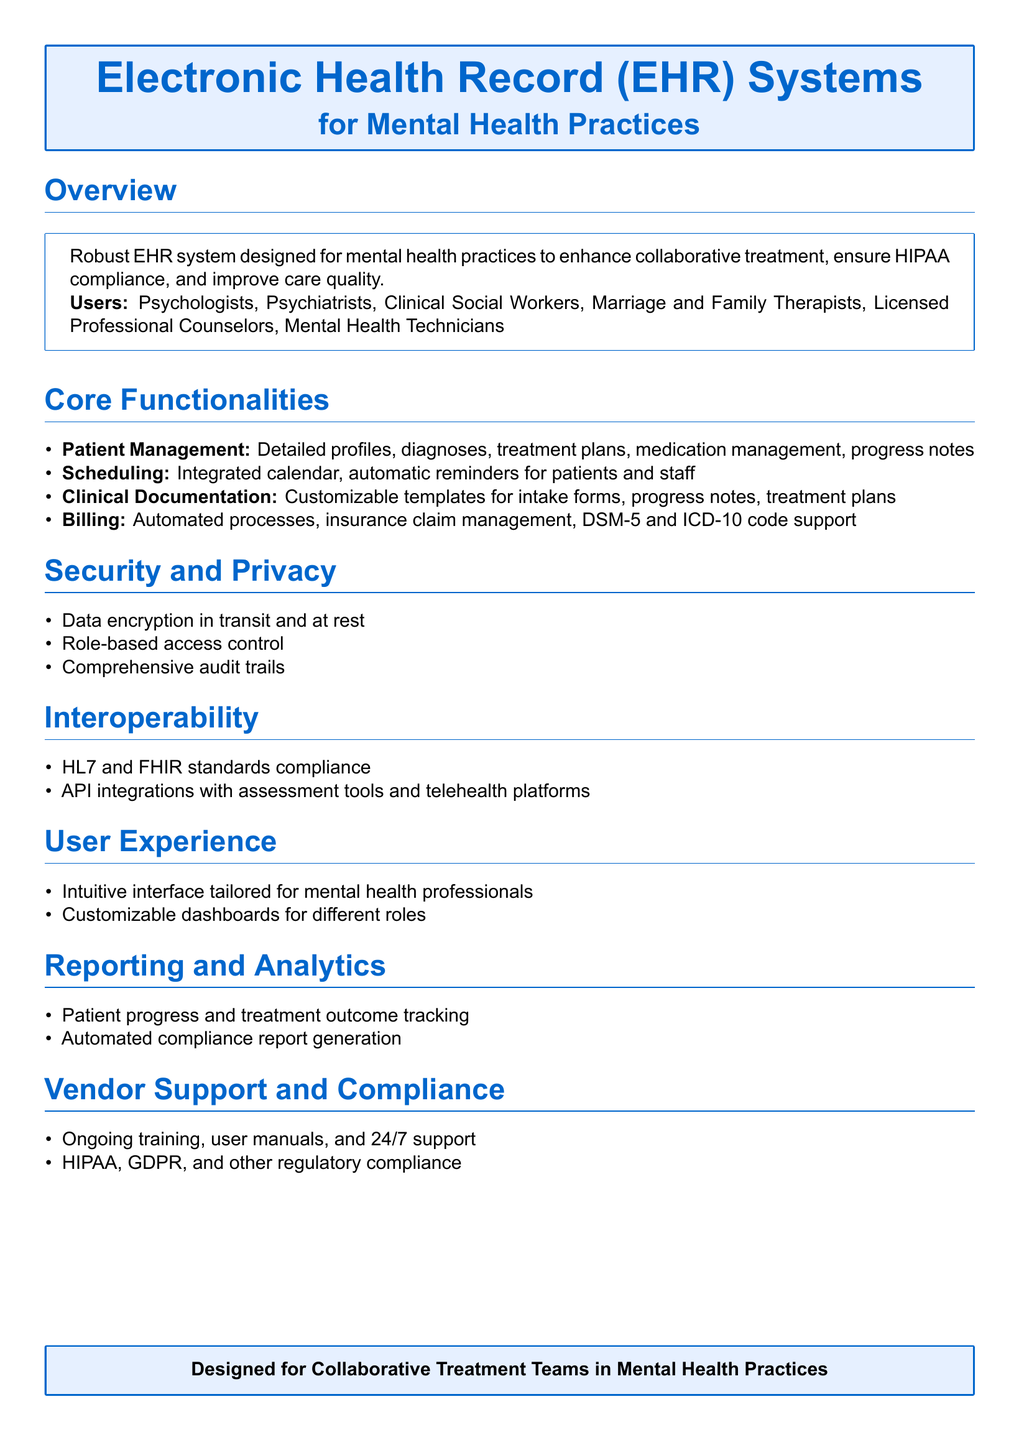What is the primary purpose of the EHR system? The primary purpose is to enhance collaborative treatment, ensure HIPAA compliance, and improve care quality.
Answer: Enhance collaborative treatment, ensure HIPAA compliance, and improve care quality Who are the intended users of the EHR system? The intended users include various mental health professionals listed in the overview section.
Answer: Psychologists, Psychiatrists, Clinical Social Workers, Marriage and Family Therapists, Licensed Professional Counselors, Mental Health Technicians What type of documentation is customizable in the EHR system? The customizable documentation types are specified in the clinical documentation section.
Answer: Intake forms, progress notes, treatment plans What encryption methods are used for data security? The document specifies the encryption methods employed for data protection.
Answer: Data encryption in transit and at rest Which compliance standards does the EHR system adhere to? The compliance standards are mentioned in the vendor support and compliance section.
Answer: HIPAA, GDPR, and other regulatory compliance What features are included in patient management? The patient management section outlines the features provided for managing patients.
Answer: Detailed profiles, diagnoses, treatment plans, medication management, progress notes How is interoperability achieved in the EHR system? The interoperability methods are detailed in the interoperability section of the document.
Answer: HL7 and FHIR standards compliance, API integrations What type of support is offered to users? The support options available are listed in the vendor support and compliance section.
Answer: Ongoing training, user manuals, and 24/7 support What type of reports can be generated with the EHR system? The reporting and analytics section describes the type of reports available.
Answer: Patient progress and treatment outcome tracking, automated compliance report generation 